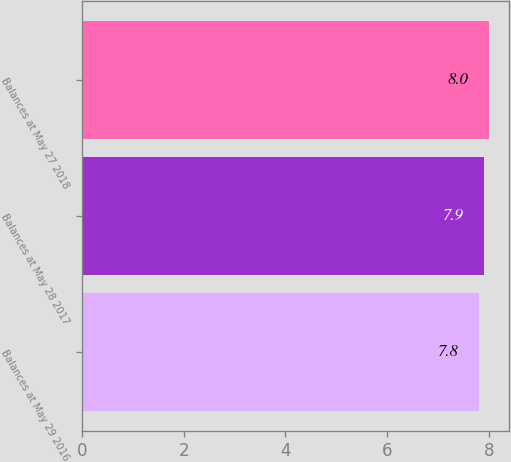Convert chart to OTSL. <chart><loc_0><loc_0><loc_500><loc_500><bar_chart><fcel>Balances at May 29 2016<fcel>Balances at May 28 2017<fcel>Balances at May 27 2018<nl><fcel>7.8<fcel>7.9<fcel>8<nl></chart> 